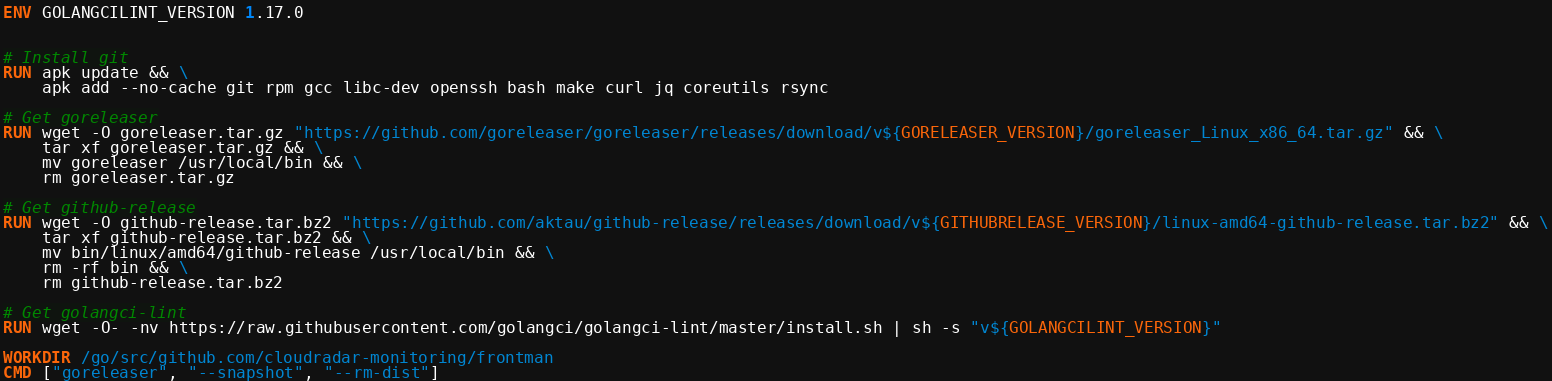<code> <loc_0><loc_0><loc_500><loc_500><_Dockerfile_>ENV GOLANGCILINT_VERSION 1.17.0


# Install git
RUN apk update && \
    apk add --no-cache git rpm gcc libc-dev openssh bash make curl jq coreutils rsync

# Get goreleaser
RUN wget -O goreleaser.tar.gz "https://github.com/goreleaser/goreleaser/releases/download/v${GORELEASER_VERSION}/goreleaser_Linux_x86_64.tar.gz" && \
    tar xf goreleaser.tar.gz && \
    mv goreleaser /usr/local/bin && \
    rm goreleaser.tar.gz

# Get github-release
RUN wget -O github-release.tar.bz2 "https://github.com/aktau/github-release/releases/download/v${GITHUBRELEASE_VERSION}/linux-amd64-github-release.tar.bz2" && \
    tar xf github-release.tar.bz2 && \
    mv bin/linux/amd64/github-release /usr/local/bin && \
    rm -rf bin && \
    rm github-release.tar.bz2

# Get golangci-lint
RUN wget -O- -nv https://raw.githubusercontent.com/golangci/golangci-lint/master/install.sh | sh -s "v${GOLANGCILINT_VERSION}"

WORKDIR /go/src/github.com/cloudradar-monitoring/frontman
CMD ["goreleaser", "--snapshot", "--rm-dist"]
</code> 